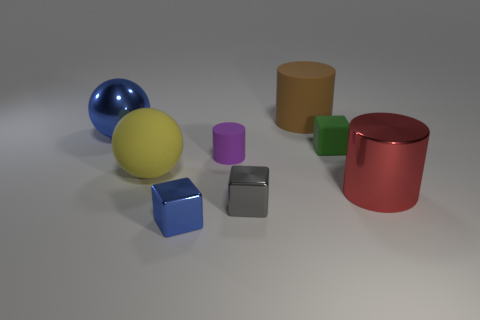Do the tiny blue cube and the brown thing have the same material?
Offer a terse response. No. There is a large blue object that is behind the small rubber object to the right of the big rubber object behind the big blue shiny thing; what is its shape?
Offer a terse response. Sphere. Is the number of spheres that are in front of the large blue metallic sphere less than the number of big yellow spheres on the right side of the red thing?
Give a very brief answer. No. There is a large metal object that is behind the large thing on the right side of the brown thing; what is its shape?
Give a very brief answer. Sphere. Is there any other thing that has the same color as the big metal ball?
Offer a terse response. Yes. What number of blue objects are either small metal cubes or tiny blocks?
Offer a very short reply. 1. Is the number of blue metal balls that are on the right side of the blue block less than the number of red metallic cylinders?
Ensure brevity in your answer.  Yes. There is a big metal thing that is in front of the big yellow rubber object; how many metallic blocks are in front of it?
Offer a very short reply. 2. What number of other objects are there of the same size as the blue metallic ball?
Make the answer very short. 3. What number of objects are shiny objects or red things in front of the big brown cylinder?
Give a very brief answer. 4. 